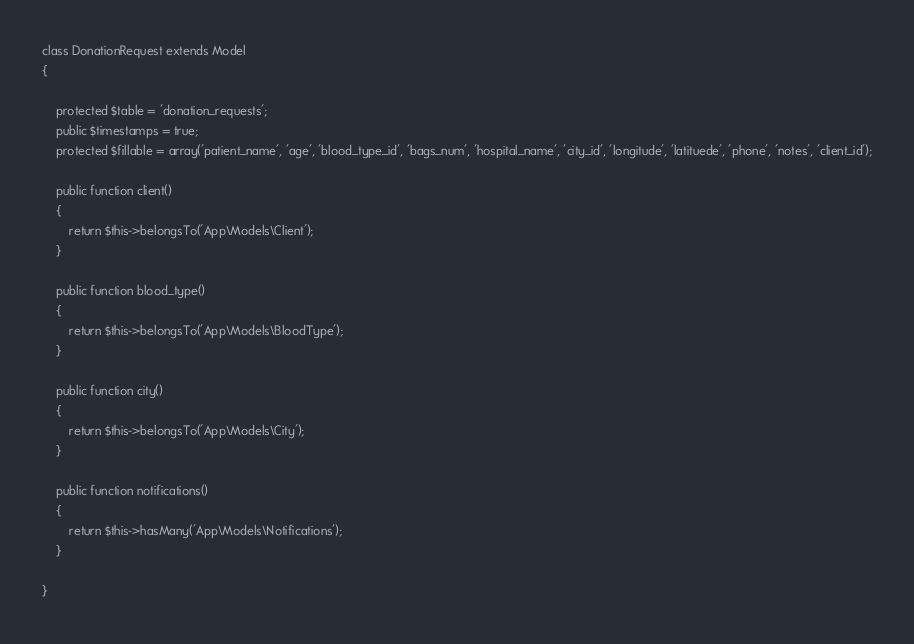Convert code to text. <code><loc_0><loc_0><loc_500><loc_500><_PHP_>class DonationRequest extends Model
{

    protected $table = 'donation_requests';
    public $timestamps = true;
    protected $fillable = array('patient_name', 'age', 'blood_type_id', 'bags_num', 'hospital_name', 'city_id', 'longitude', 'latituede', 'phone', 'notes', 'client_id');

    public function client()
    {
        return $this->belongsTo('App\Models\Client');
    }

    public function blood_type()
    {
        return $this->belongsTo('App\Models\BloodType');
    }

    public function city()
    {
        return $this->belongsTo('App\Models\City');
    }

    public function notifications()
    {
        return $this->hasMany('App\Models\Notifications');
    }

}
</code> 